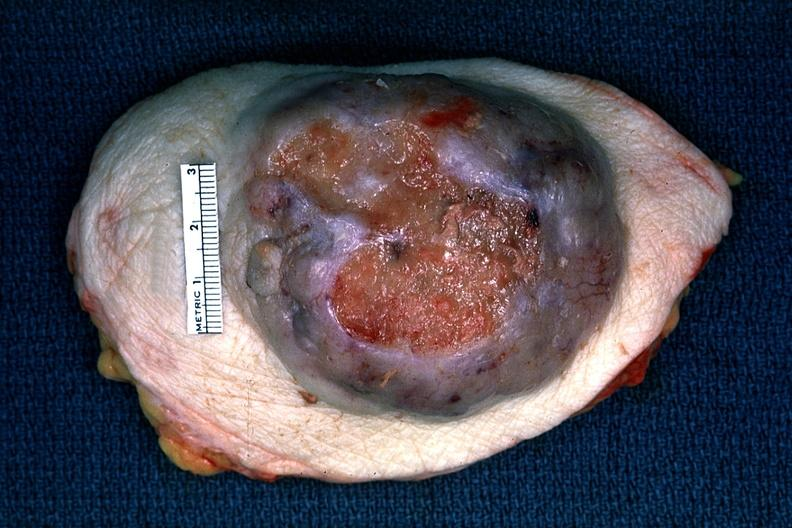does this image show huge ulcerating carcinoma surgical specimen?
Answer the question using a single word or phrase. Yes 